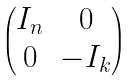<formula> <loc_0><loc_0><loc_500><loc_500>\begin{pmatrix} I _ { n } & 0 \\ 0 & - I _ { k } \end{pmatrix}</formula> 